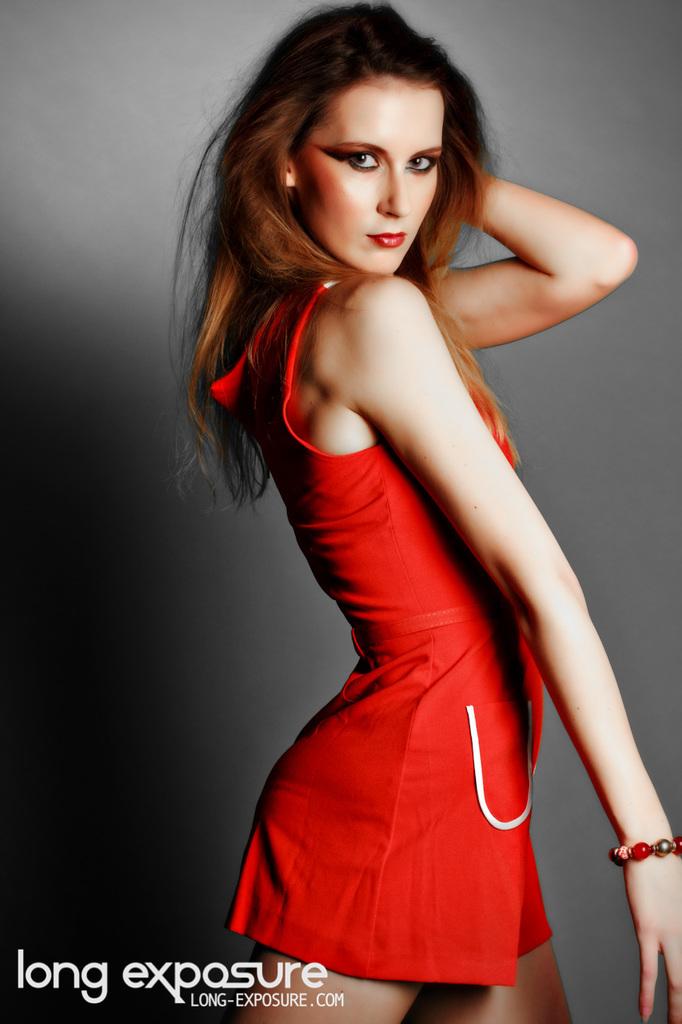What company is this an advertisement for?
Give a very brief answer. Long exposure. What website is shown on this photo?
Ensure brevity in your answer.  Long-exposure.com. 